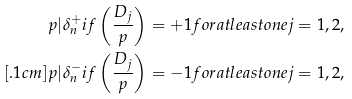Convert formula to latex. <formula><loc_0><loc_0><loc_500><loc_500>p | \delta _ { n } ^ { + } & i f \left ( \frac { D _ { j } } { p } \right ) = + 1 f o r a t l e a s t o n e j = 1 , 2 , \\ [ . 1 c m ] p | \delta _ { n } ^ { - } & i f \left ( \frac { D _ { j } } { p } \right ) = - 1 f o r a t l e a s t o n e j = 1 , 2 ,</formula> 